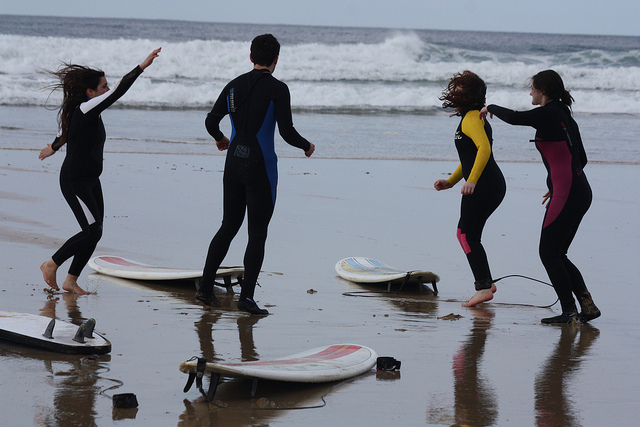Can you tell if they're experienced surfers? It's difficult to determine their experience level from the image alone, but the placement of the surfboards on the sand and the relaxed body language might imply they're in a learning phase or enjoying a casual day out. 